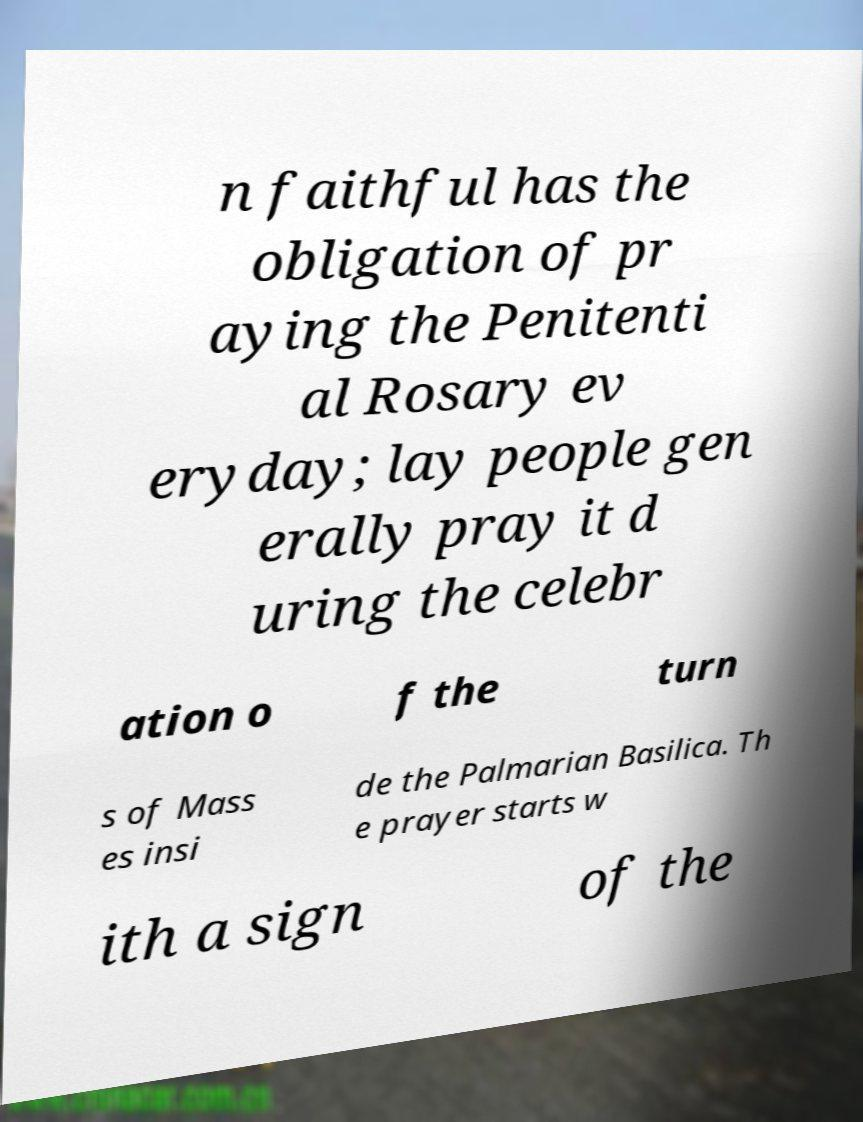Could you extract and type out the text from this image? n faithful has the obligation of pr aying the Penitenti al Rosary ev eryday; lay people gen erally pray it d uring the celebr ation o f the turn s of Mass es insi de the Palmarian Basilica. Th e prayer starts w ith a sign of the 